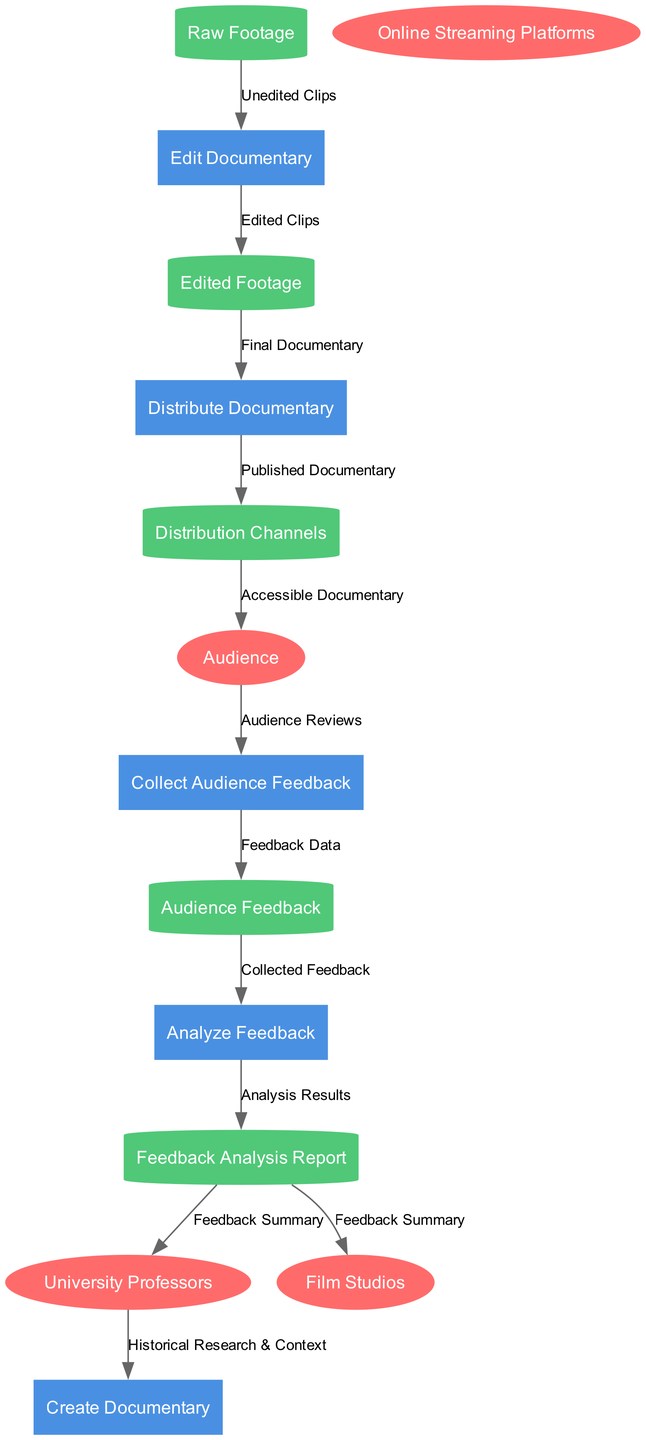What is the first process in the flow? The first process in the flow diagram is labeled as "Create Documentary," which is the initiation step leading to the subsequent processes.
Answer: Create Documentary How many external entities are present in the diagram? The diagram includes four external entities, specifically "University Professors," "Film Studios," "Online Streaming Platforms," and "Audience."
Answer: 4 What type of data is collected from the audience? The data collected from the audience is labeled as "Audience Reviews," which are the inputs for gathering audience feedback.
Answer: Audience Reviews Which process outputs the "Final Documentary"? The process that outputs "Final Documentary" is "Edit Documentary," which processes "Edited Footage" to create the final product before distribution.
Answer: Edit Documentary What do "University Professors" provide for the first process? "University Professors" provide "Historical Research & Context" as inputs for the "Create Documentary" process, which helps inform the documentary's content.
Answer: Historical Research & Context What is the last data store in the feedback analysis process? The last data store in the feedback analysis process is "Feedback Analysis Report," which contains the results of the feedback analysis conducted on the audience data.
Answer: Feedback Analysis Report Where does "Accessible Documentary" flow to after distribution? After distribution, "Accessible Documentary" flows to the "Audience," making the content available for viewers.
Answer: Audience Which process receives data from "Audience Feedback"? The process that receives data from "Audience Feedback" is "Analyze Feedback," which processes the collected feedback for analysis.
Answer: Analyze Feedback What summary is provided to "Film Studios"? The output provided to "Film Studios" from the feedback analysis is the "Feedback Summary," which summarizes the audience's feedback for further insights.
Answer: Feedback Summary 